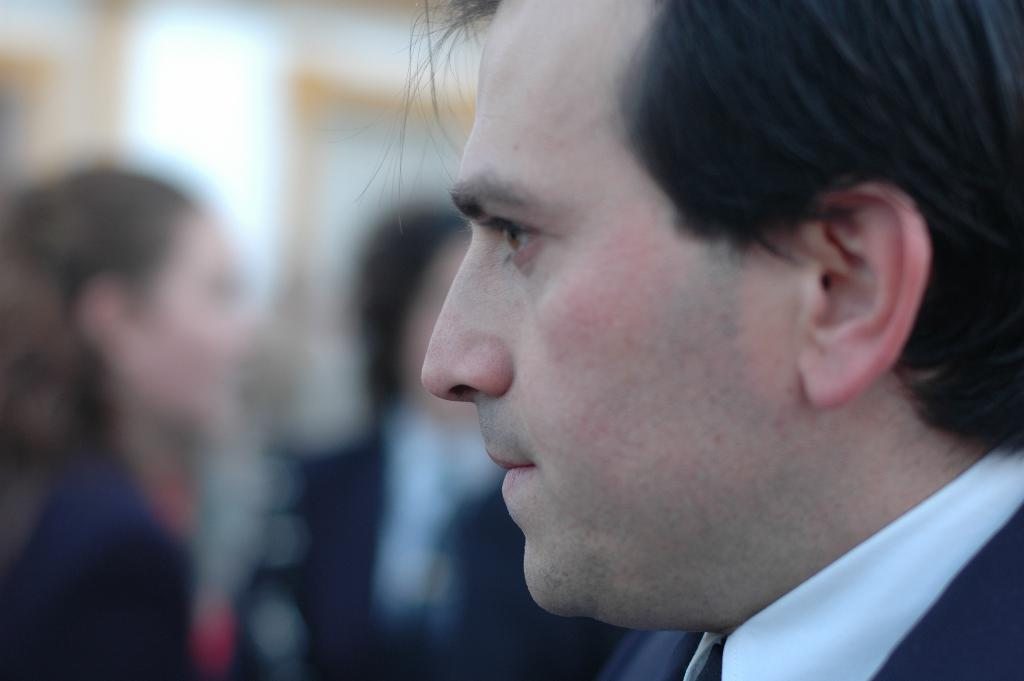Who is the main subject in the image? There is a man in the image. Can you describe the setting of the image? The image features a man, and there are people in the background. What type of treatment is the man receiving in the image? There is no indication in the image that the man is receiving any treatment. 